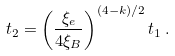<formula> <loc_0><loc_0><loc_500><loc_500>t _ { 2 } = \left ( \frac { \xi _ { e } } { 4 \xi _ { B } } \right ) ^ { ( 4 - k ) / 2 } t _ { 1 } \, .</formula> 